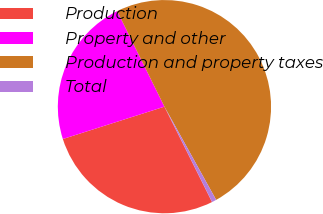Convert chart to OTSL. <chart><loc_0><loc_0><loc_500><loc_500><pie_chart><fcel>Production<fcel>Property and other<fcel>Production and property taxes<fcel>Total<nl><fcel>27.46%<fcel>22.6%<fcel>49.25%<fcel>0.69%<nl></chart> 